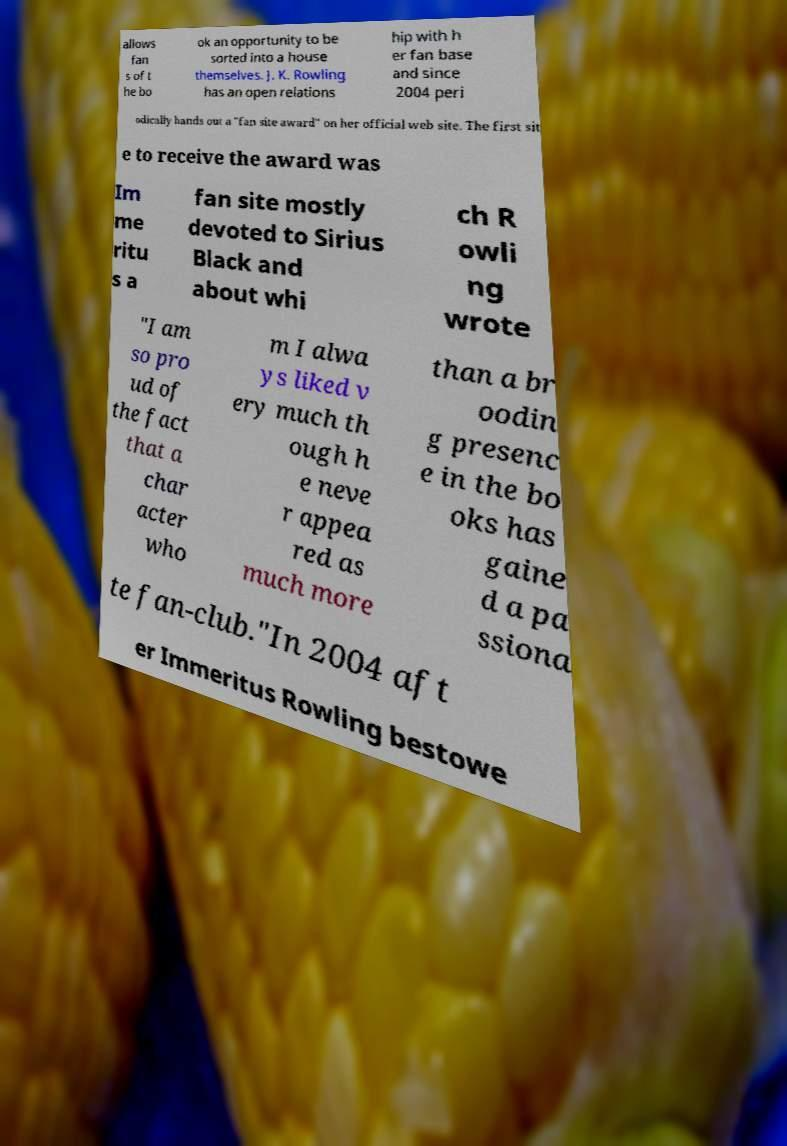Please read and relay the text visible in this image. What does it say? allows fan s of t he bo ok an opportunity to be sorted into a house themselves. J. K. Rowling has an open relations hip with h er fan base and since 2004 peri odically hands out a "fan site award" on her official web site. The first sit e to receive the award was Im me ritu s a fan site mostly devoted to Sirius Black and about whi ch R owli ng wrote "I am so pro ud of the fact that a char acter who m I alwa ys liked v ery much th ough h e neve r appea red as much more than a br oodin g presenc e in the bo oks has gaine d a pa ssiona te fan-club."In 2004 aft er Immeritus Rowling bestowe 